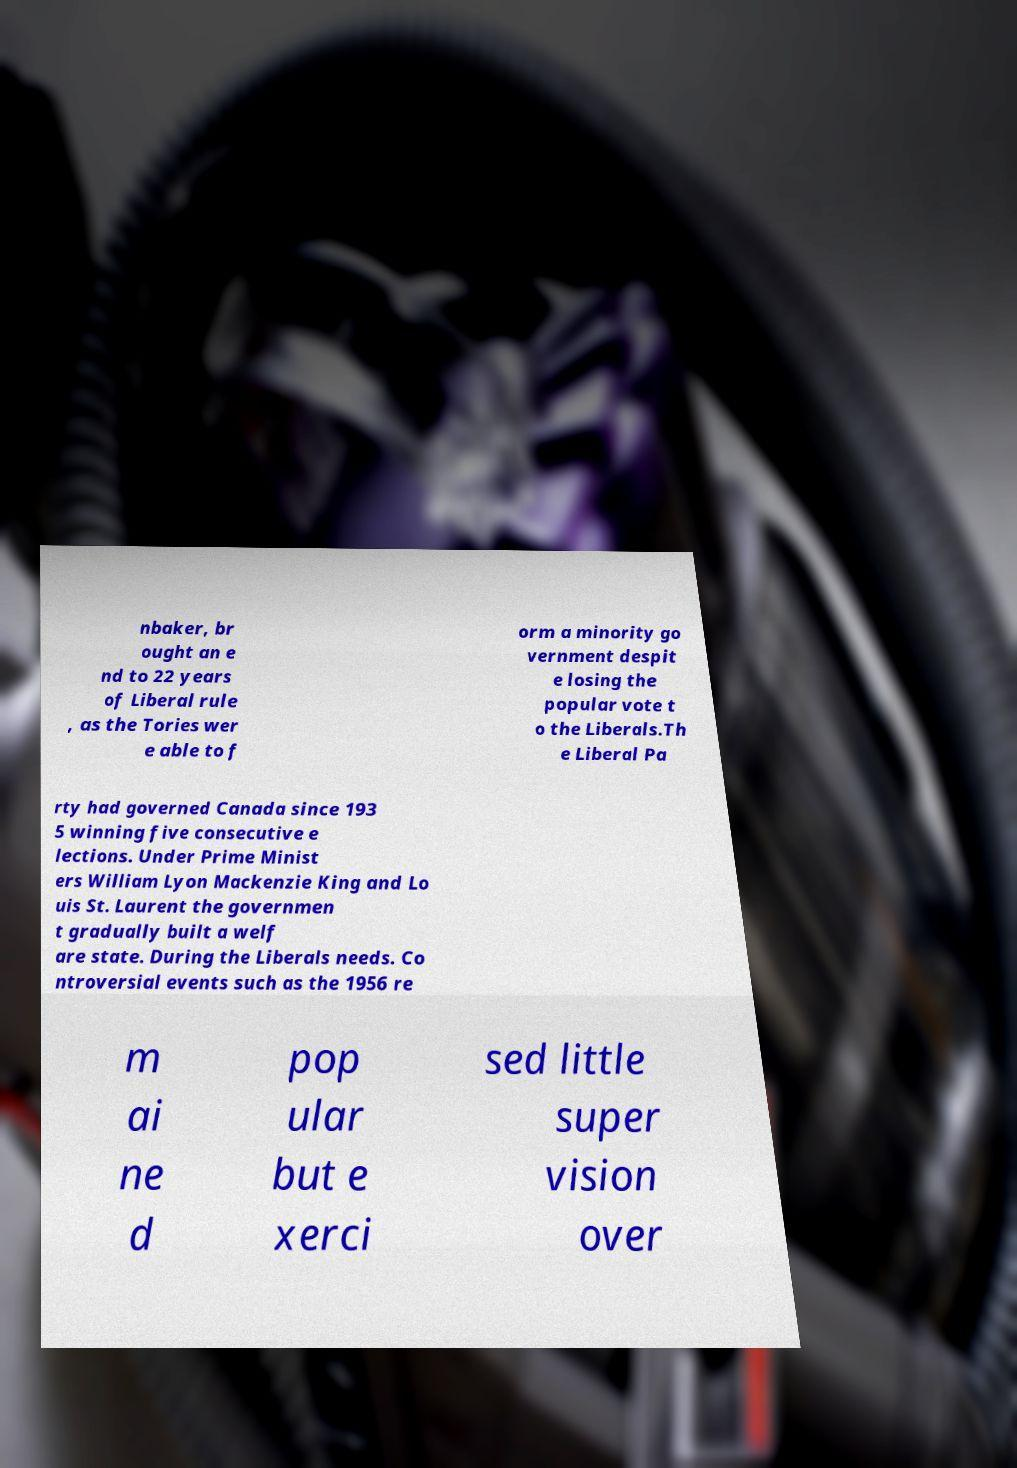Could you extract and type out the text from this image? nbaker, br ought an e nd to 22 years of Liberal rule , as the Tories wer e able to f orm a minority go vernment despit e losing the popular vote t o the Liberals.Th e Liberal Pa rty had governed Canada since 193 5 winning five consecutive e lections. Under Prime Minist ers William Lyon Mackenzie King and Lo uis St. Laurent the governmen t gradually built a welf are state. During the Liberals needs. Co ntroversial events such as the 1956 re m ai ne d pop ular but e xerci sed little super vision over 